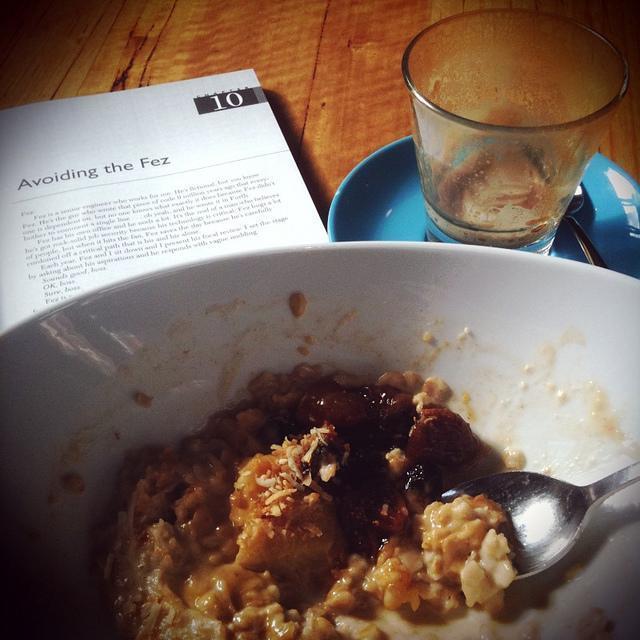How many bowls are in the photo?
Give a very brief answer. 1. How many red umbrellas do you see?
Give a very brief answer. 0. 